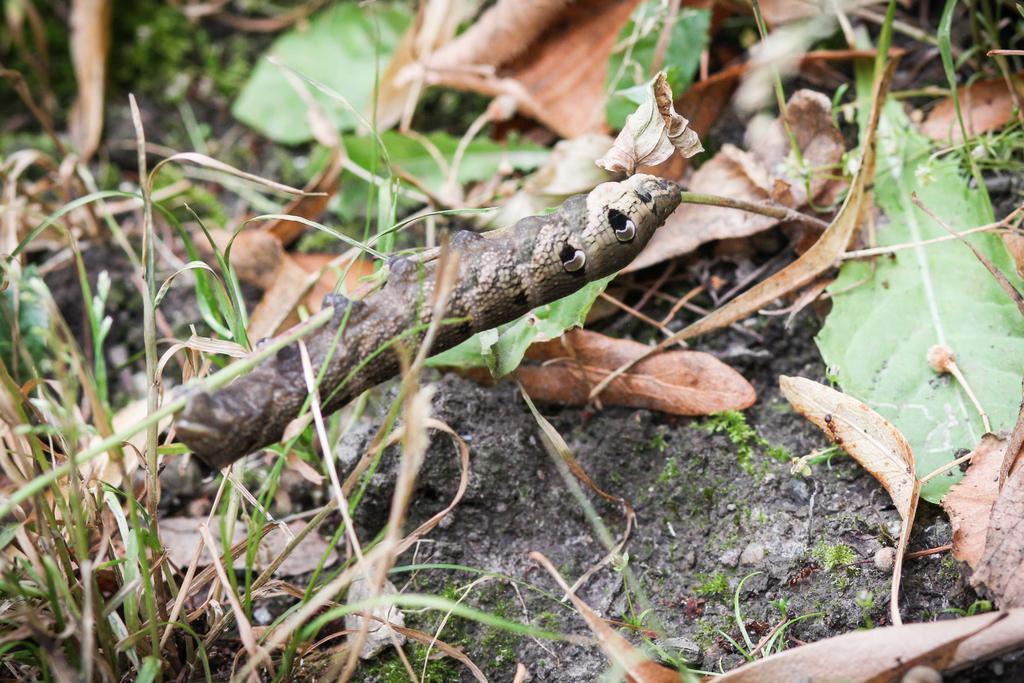Could you give a brief overview of what you see in this image? In this picture we can observe a caterpillar which is in brown color. There are some dried leaves on the ground. We can observe some grass. 